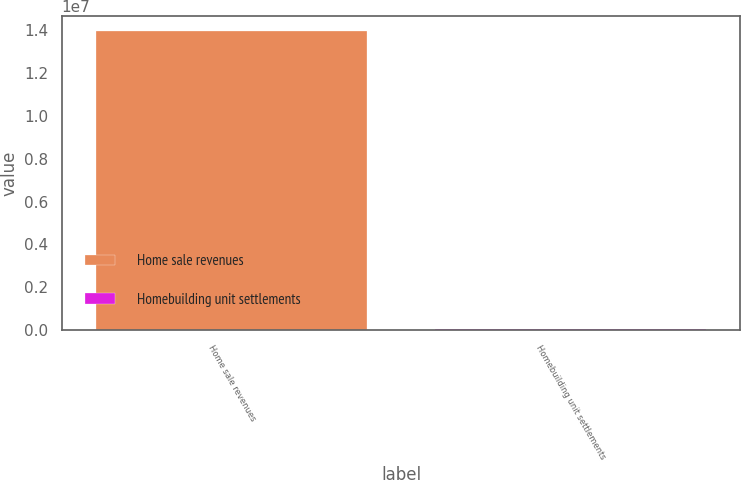<chart> <loc_0><loc_0><loc_500><loc_500><bar_chart><fcel>Home sale revenues<fcel>Homebuilding unit settlements<nl><fcel>1.39754e+07<fcel>41487<nl></chart> 